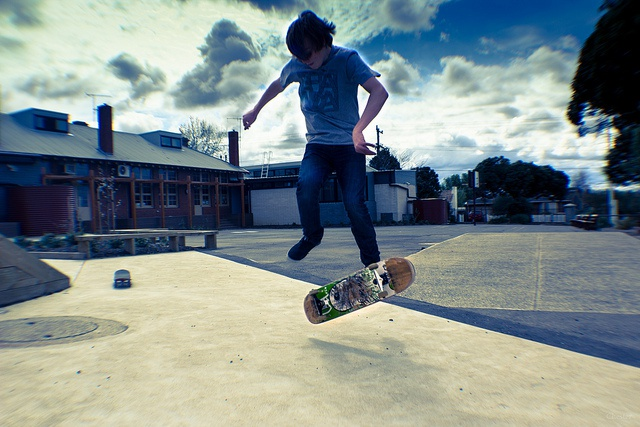Describe the objects in this image and their specific colors. I can see people in gray, black, navy, white, and purple tones, skateboard in gray, black, darkgray, and navy tones, bench in gray, navy, black, and darkblue tones, and skateboard in gray, navy, and blue tones in this image. 